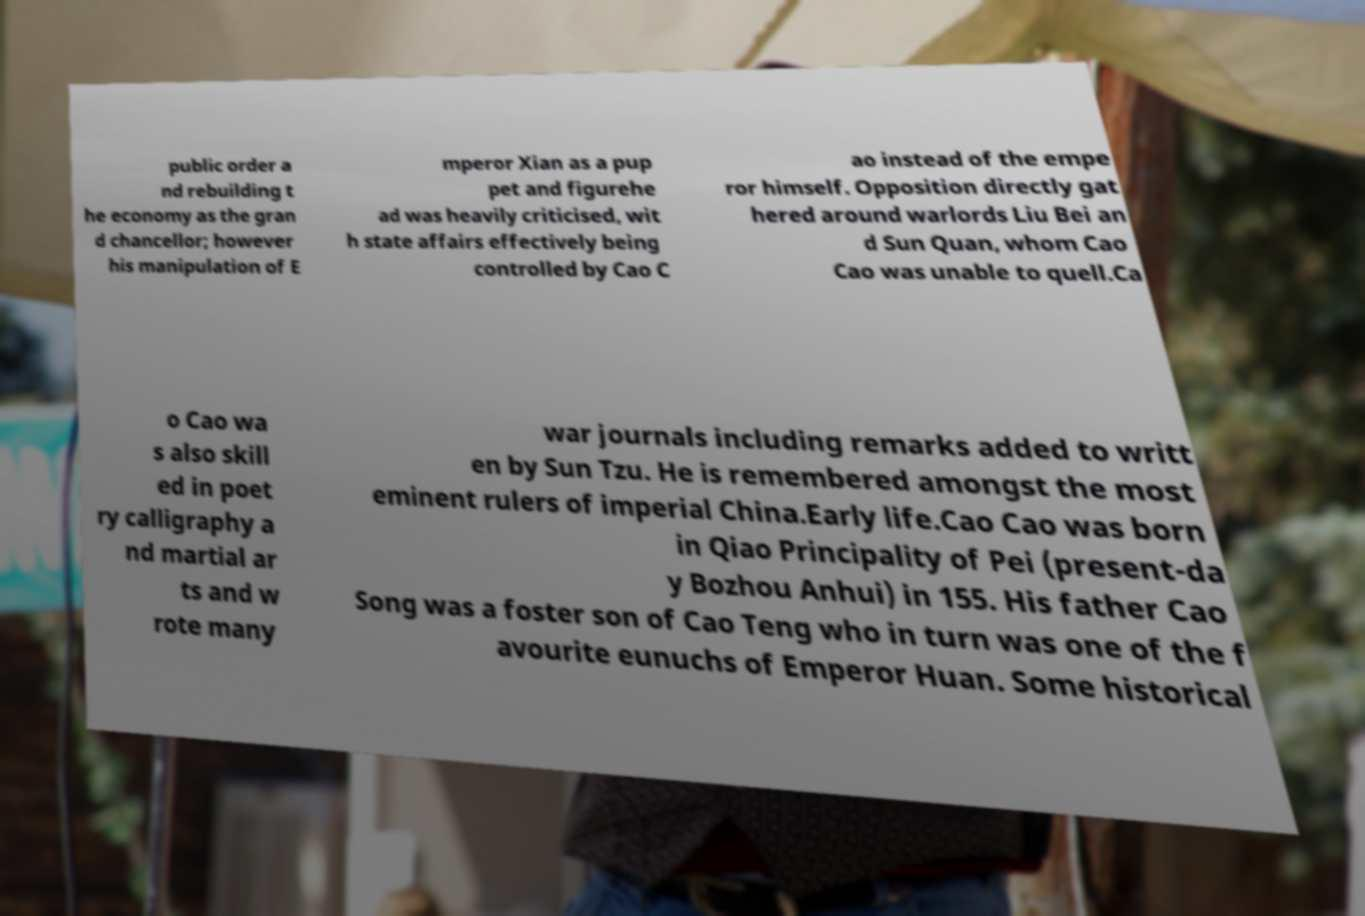Can you read and provide the text displayed in the image?This photo seems to have some interesting text. Can you extract and type it out for me? public order a nd rebuilding t he economy as the gran d chancellor; however his manipulation of E mperor Xian as a pup pet and figurehe ad was heavily criticised, wit h state affairs effectively being controlled by Cao C ao instead of the empe ror himself. Opposition directly gat hered around warlords Liu Bei an d Sun Quan, whom Cao Cao was unable to quell.Ca o Cao wa s also skill ed in poet ry calligraphy a nd martial ar ts and w rote many war journals including remarks added to writt en by Sun Tzu. He is remembered amongst the most eminent rulers of imperial China.Early life.Cao Cao was born in Qiao Principality of Pei (present-da y Bozhou Anhui) in 155. His father Cao Song was a foster son of Cao Teng who in turn was one of the f avourite eunuchs of Emperor Huan. Some historical 